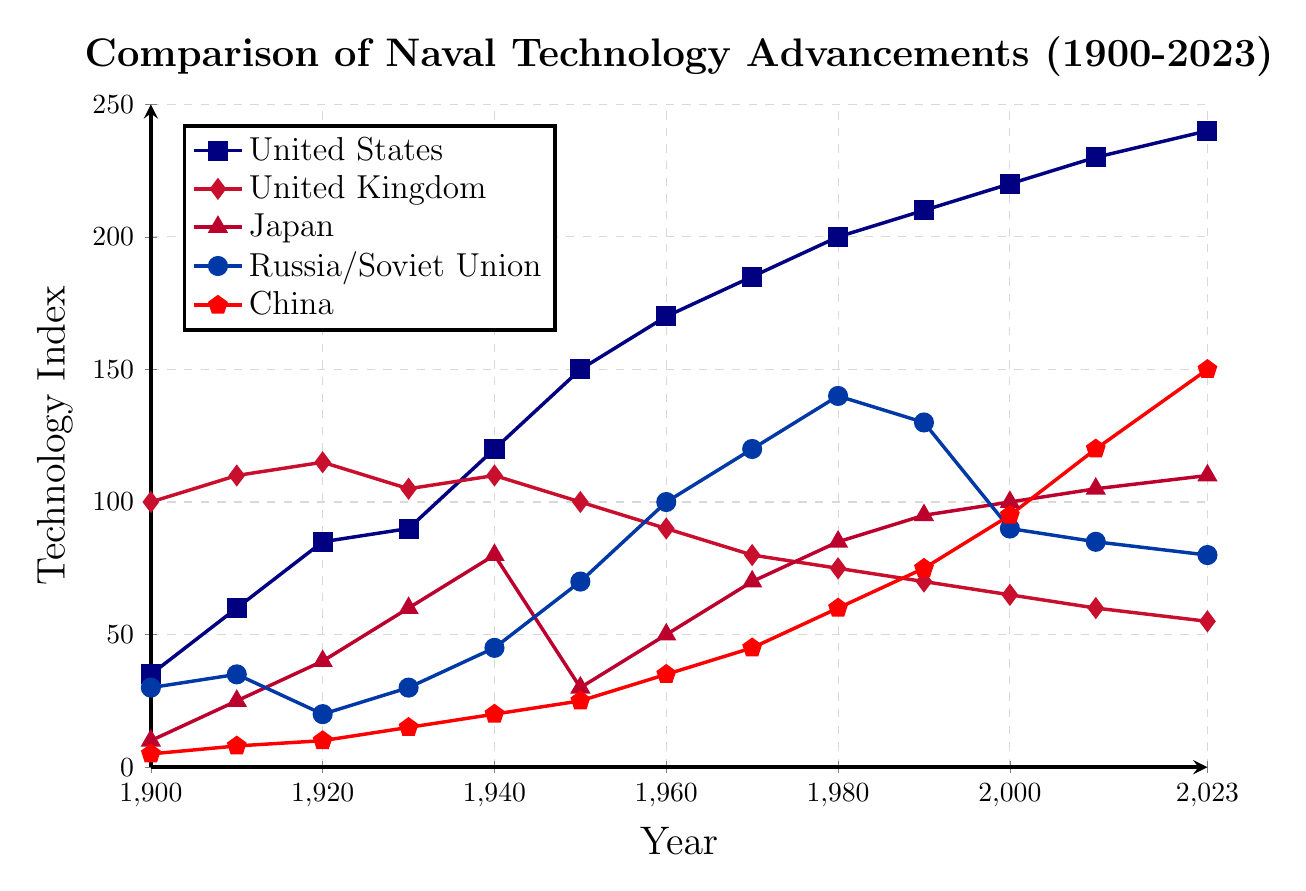What year did China surpass Russia/Soviet Union in naval technology advancements? To find the year China surpassed Russia, we look for the point at which the red pentagon (China) line exceeds the blue circle (Russia) line. This happens between 2000 and 2010. By checking these specific years, we observe that in 2010, China’s index (120) surpasses Russia’s 85, which was lower than Russia's 90 in the year 2000.
Answer: 2010 Which country had the most significant increase in naval technology advancements during the 20th century? We need to find the country with the greatest change in the technology index from 1900 to 2000. The United States starts at 35 and ends at 220, giving an increase of 185. The United Kingdom’s index changes from 100 to 65, Japan from 10 to 100, Russia from 30 to 90, and China from 5 to 95. The United States shows the largest increase.
Answer: United States What was the technology index difference between Japan and the United Kingdom in 1920? To find the difference, subtract Japan’s 1920 index from the United Kingdom’s 1920 index. The United Kingdom has an index of 115, and Japan has 40. The difference is 115 - 40 = 75.
Answer: 75 How has the United Kingdom’s naval technology index trended over the years? By examining the visual trend of the United Kingdom's data (red diamonds), we see a general decline from 100 in 1900 to 55 in 2023. Although there is a peak around 1920-1940, the overall downward trend is evident.
Answer: Downward trend Which two countries had the closest naval technology indices in 1940? In 1940, comparing the indices of all countries, the closest values are between the United Kingdom (110) and the United States (120), with a difference of 10.
Answer: United States and United Kingdom What trend can be seen in China’s naval technology index since 1980? From 1980 onwards, examining the red pentagon markers for China shows a clear upward trend starting from 60 in 1980 and rising to 150 in 2023.
Answer: Increasing trend How did Russia’s naval technology index change in the decade between 1960 and 1970? The index for Russia in 1960 was 100 and it increased to 120 by 1970. To find the change, subtract the 1960 value from the 1970 value: 120 - 100 = 20.
Answer: Increased by 20 Which country had the highest naval technology index in 2023? Observing the endpoints of each line in 2023, the United States (blue squares) has the highest value at 240.
Answer: United States Between 1910 and 1920, which country had the largest increase in their naval technology index? To determine this, we calculate the increase for each country: The United States increased by 25 (60 to 85), the United Kingdom by 5 (110 to 115), Japan by 15 (25 to 40), Russia/Soviet Union decreased by 15 (35 to 20), and China by 2 (8 to 10). The United States had the largest increase.
Answer: United States 